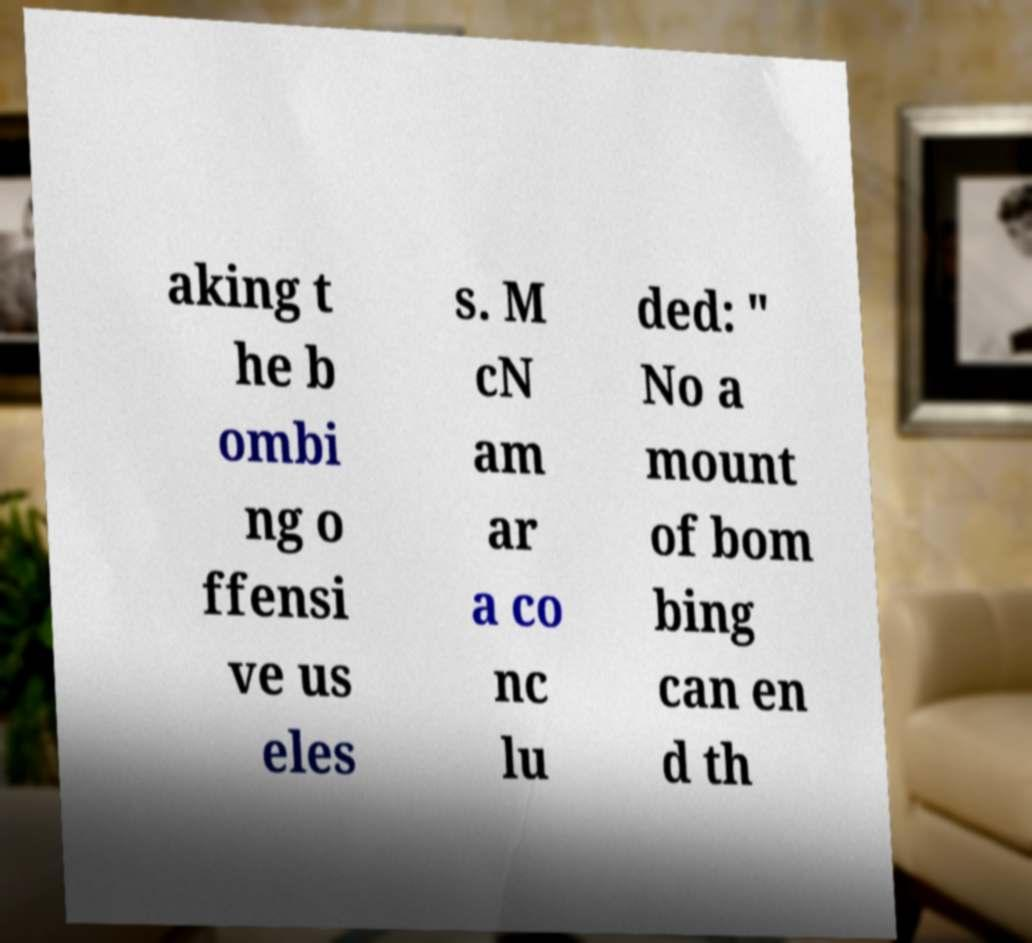What messages or text are displayed in this image? I need them in a readable, typed format. aking t he b ombi ng o ffensi ve us eles s. M cN am ar a co nc lu ded: " No a mount of bom bing can en d th 